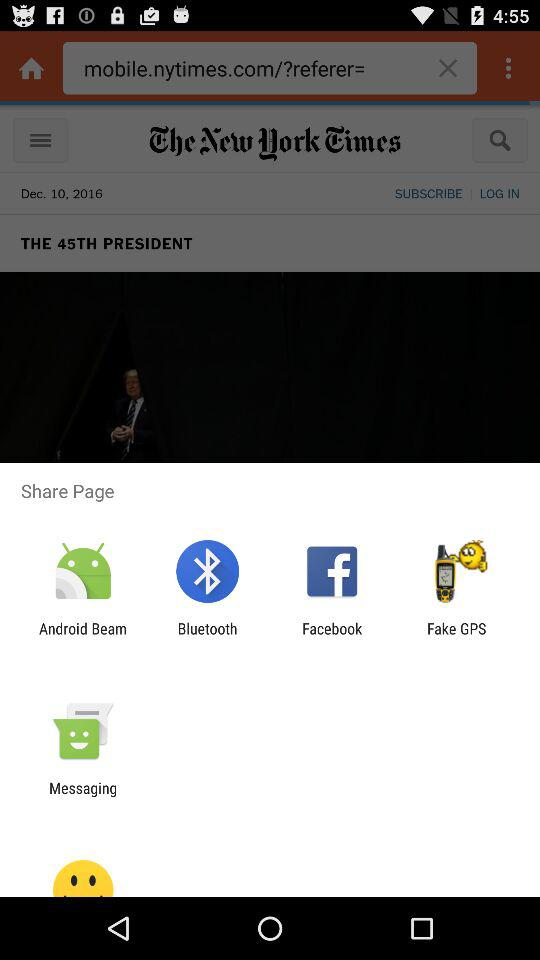When was the news posted? The news was posted on December 10, 2016. 